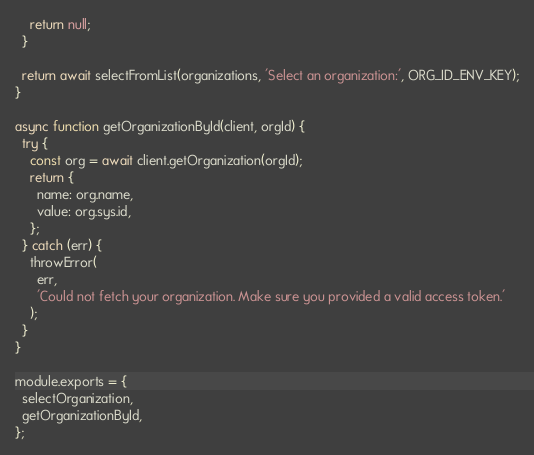Convert code to text. <code><loc_0><loc_0><loc_500><loc_500><_JavaScript_>    return null;
  }

  return await selectFromList(organizations, 'Select an organization:', ORG_ID_ENV_KEY);
}

async function getOrganizationById(client, orgId) {
  try {
    const org = await client.getOrganization(orgId);
    return {
      name: org.name,
      value: org.sys.id,
    };
  } catch (err) {
    throwError(
      err,
      'Could not fetch your organization. Make sure you provided a valid access token.'
    );
  }
}

module.exports = {
  selectOrganization,
  getOrganizationById,
};
</code> 